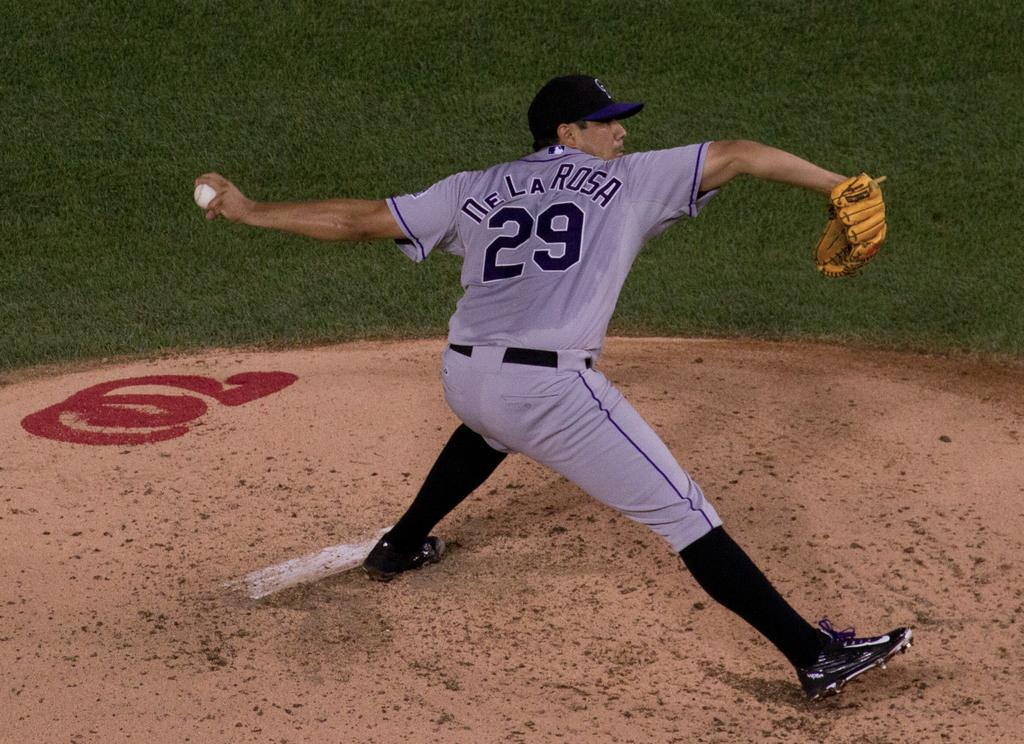<image>
Give a short and clear explanation of the subsequent image. number 29 DeLaRosa on the baseball mound pitching 